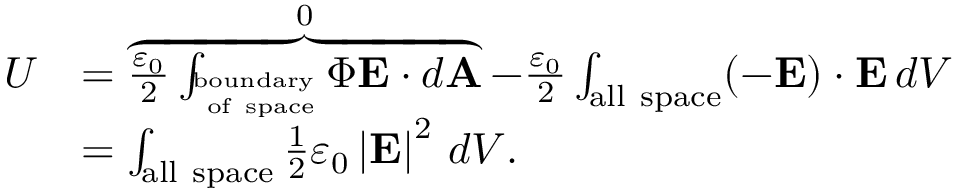<formula> <loc_0><loc_0><loc_500><loc_500>{ \begin{array} { r l } { U } & { = \overbrace { { \frac { \varepsilon _ { 0 } } { 2 } } \int _ { _ { o f s p a c e } ^ { b o u n d a r y } } \Phi E \cdot d A } ^ { 0 } - { \frac { \varepsilon _ { 0 } } { 2 } } \int _ { a l l s p a c e } ( - E ) \cdot E \, d V } \\ & { = \int _ { a l l s p a c e } { \frac { 1 } { 2 } } \varepsilon _ { 0 } \left | { E } \right | ^ { 2 } \, d V . } \end{array} }</formula> 